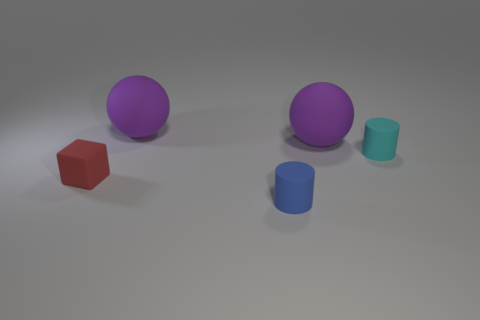There is a object that is on the left side of the cyan matte cylinder and on the right side of the blue rubber thing; what shape is it?
Your response must be concise. Sphere. What color is the matte ball that is to the left of the large object on the right side of the tiny cylinder in front of the tiny red thing?
Provide a succinct answer. Purple. Is the number of objects that are to the left of the blue thing greater than the number of tiny things behind the small cyan matte object?
Your answer should be compact. Yes. How many other things are the same size as the cyan object?
Offer a very short reply. 2. The large purple sphere that is in front of the ball that is on the left side of the tiny blue rubber thing is made of what material?
Provide a short and direct response. Rubber. Are there any small blue matte cylinders to the left of the small red cube?
Provide a succinct answer. No. Is the number of matte things that are left of the tiny red object greater than the number of green matte balls?
Your answer should be very brief. No. Are there any large cylinders that have the same color as the small block?
Give a very brief answer. No. What color is the rubber cube that is the same size as the blue rubber thing?
Give a very brief answer. Red. There is a matte thing in front of the red rubber block; is there a tiny blue rubber thing to the left of it?
Your answer should be compact. No. 